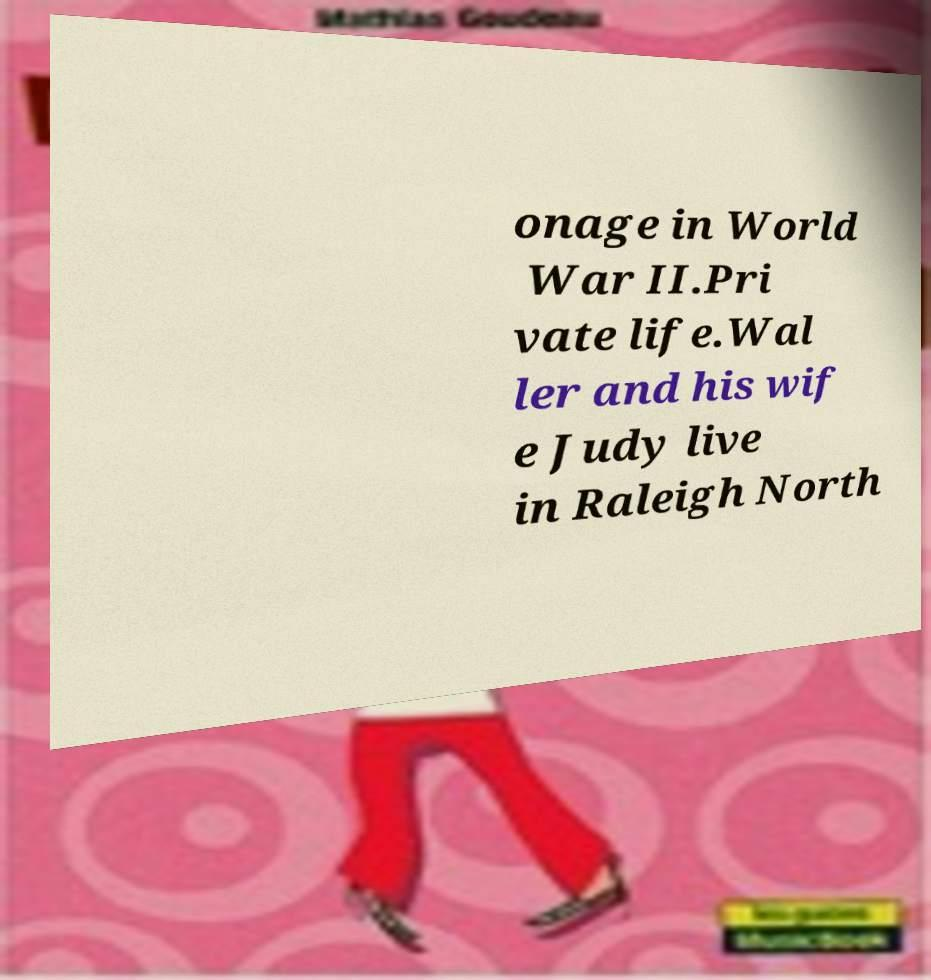Please read and relay the text visible in this image. What does it say? onage in World War II.Pri vate life.Wal ler and his wif e Judy live in Raleigh North 